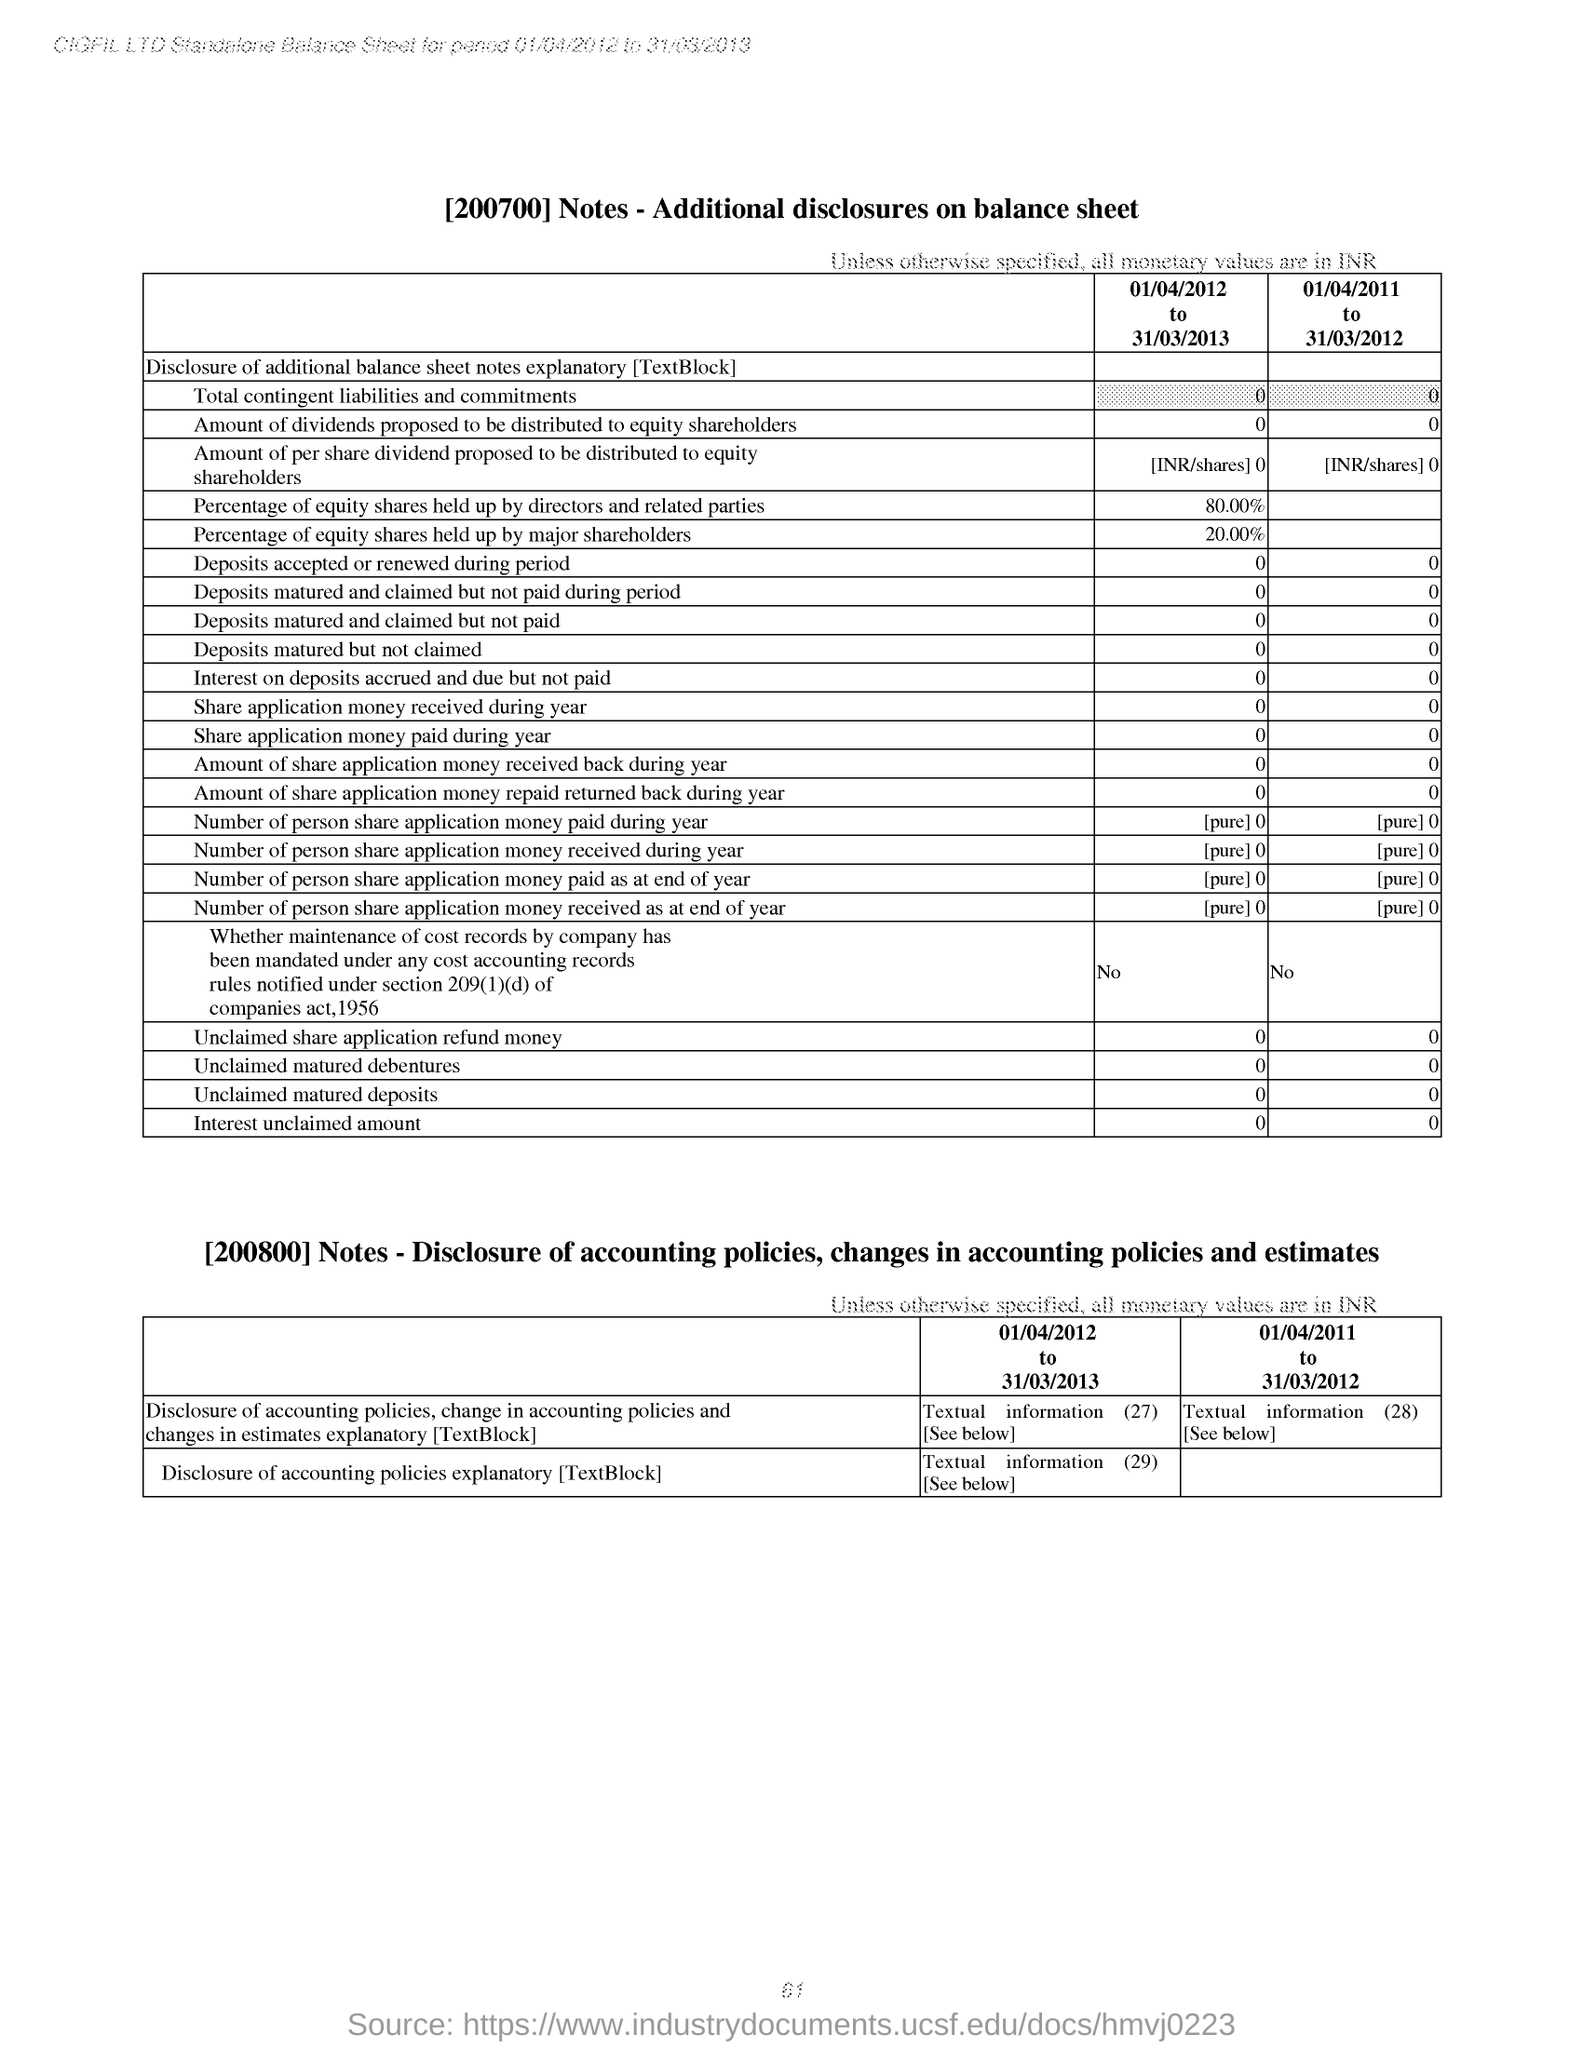What is the Percentage of equity shares held up by major shareholders from 01/04/2012 to 31/03/2013??
 20.00% 